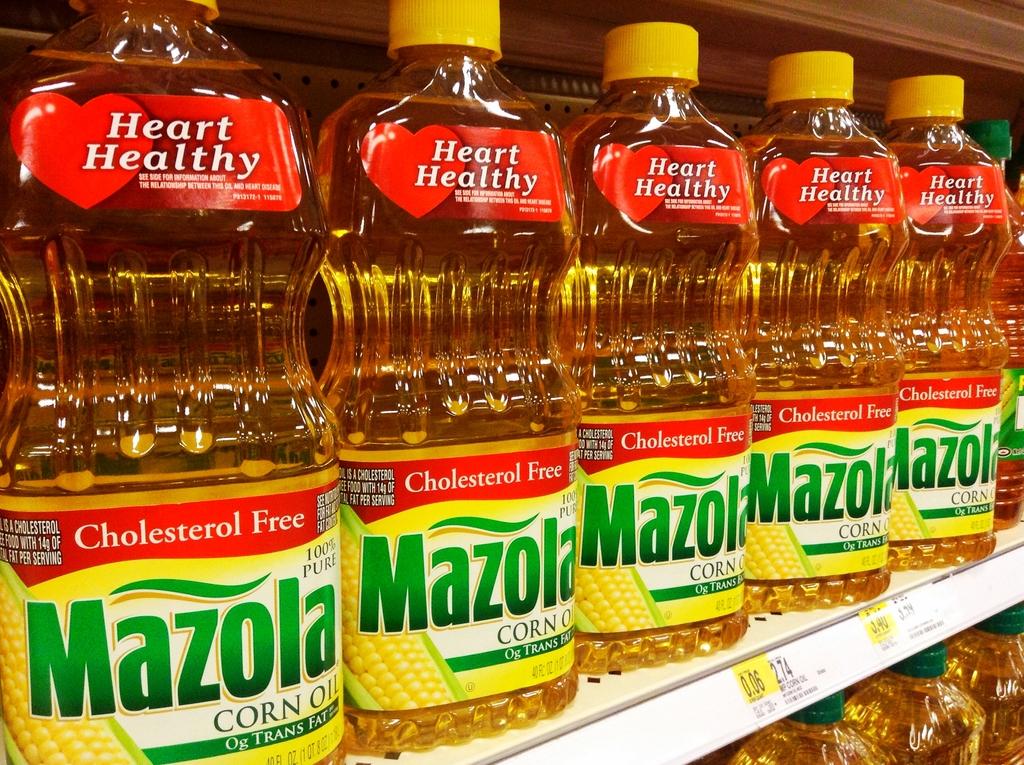Are these safe for your heart?
Your response must be concise. Yes. What is the brand?
Make the answer very short. Mazola. 